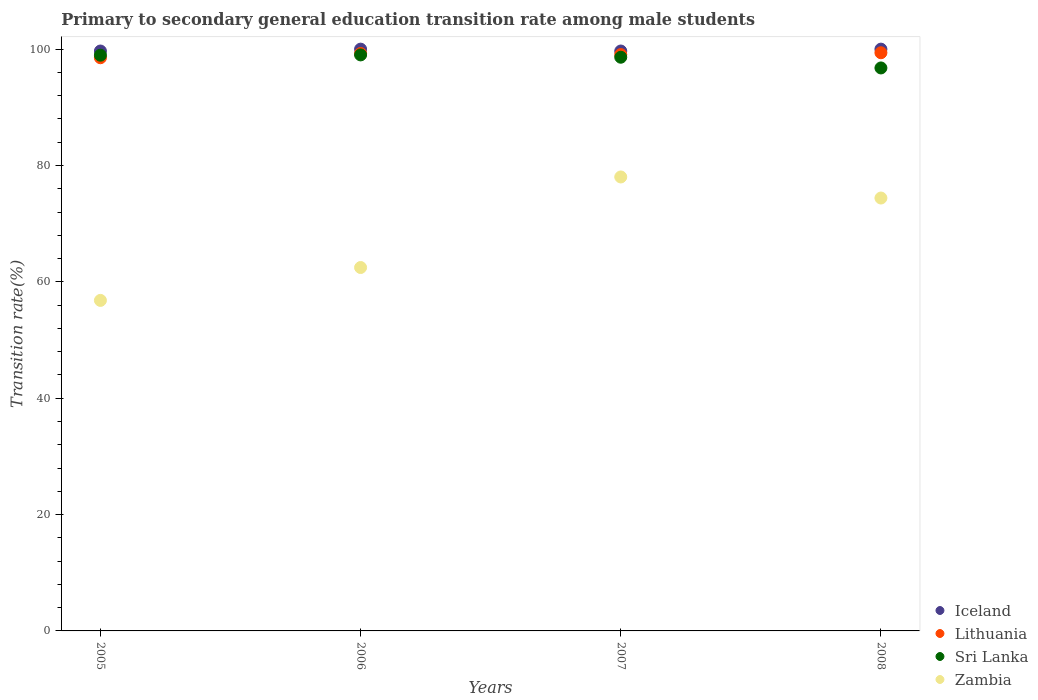Is the number of dotlines equal to the number of legend labels?
Your response must be concise. Yes. What is the transition rate in Lithuania in 2007?
Your answer should be compact. 99.07. Across all years, what is the maximum transition rate in Lithuania?
Give a very brief answer. 99.38. Across all years, what is the minimum transition rate in Sri Lanka?
Provide a short and direct response. 96.77. What is the total transition rate in Lithuania in the graph?
Make the answer very short. 396.22. What is the difference between the transition rate in Sri Lanka in 2006 and that in 2008?
Offer a very short reply. 2.24. What is the difference between the transition rate in Sri Lanka in 2006 and the transition rate in Lithuania in 2005?
Your answer should be compact. 0.49. What is the average transition rate in Sri Lanka per year?
Offer a very short reply. 98.34. In the year 2005, what is the difference between the transition rate in Sri Lanka and transition rate in Iceland?
Your response must be concise. -0.72. What is the ratio of the transition rate in Iceland in 2005 to that in 2008?
Offer a very short reply. 1. Is the transition rate in Lithuania in 2005 less than that in 2007?
Your response must be concise. Yes. What is the difference between the highest and the second highest transition rate in Zambia?
Ensure brevity in your answer.  3.62. What is the difference between the highest and the lowest transition rate in Lithuania?
Your answer should be compact. 0.86. In how many years, is the transition rate in Lithuania greater than the average transition rate in Lithuania taken over all years?
Your answer should be compact. 3. Is the transition rate in Sri Lanka strictly greater than the transition rate in Lithuania over the years?
Offer a very short reply. No. How are the legend labels stacked?
Provide a short and direct response. Vertical. What is the title of the graph?
Ensure brevity in your answer.  Primary to secondary general education transition rate among male students. What is the label or title of the Y-axis?
Your answer should be very brief. Transition rate(%). What is the Transition rate(%) in Iceland in 2005?
Give a very brief answer. 99.68. What is the Transition rate(%) of Lithuania in 2005?
Your answer should be compact. 98.52. What is the Transition rate(%) of Sri Lanka in 2005?
Keep it short and to the point. 98.96. What is the Transition rate(%) in Zambia in 2005?
Your answer should be compact. 56.81. What is the Transition rate(%) of Iceland in 2006?
Make the answer very short. 100. What is the Transition rate(%) of Lithuania in 2006?
Provide a short and direct response. 99.25. What is the Transition rate(%) in Sri Lanka in 2006?
Offer a very short reply. 99.01. What is the Transition rate(%) of Zambia in 2006?
Your answer should be compact. 62.46. What is the Transition rate(%) of Iceland in 2007?
Give a very brief answer. 99.68. What is the Transition rate(%) of Lithuania in 2007?
Your answer should be very brief. 99.07. What is the Transition rate(%) of Sri Lanka in 2007?
Your answer should be very brief. 98.61. What is the Transition rate(%) of Zambia in 2007?
Give a very brief answer. 78.03. What is the Transition rate(%) of Iceland in 2008?
Your answer should be very brief. 100. What is the Transition rate(%) in Lithuania in 2008?
Make the answer very short. 99.38. What is the Transition rate(%) of Sri Lanka in 2008?
Ensure brevity in your answer.  96.77. What is the Transition rate(%) of Zambia in 2008?
Provide a short and direct response. 74.41. Across all years, what is the maximum Transition rate(%) of Iceland?
Your answer should be very brief. 100. Across all years, what is the maximum Transition rate(%) of Lithuania?
Give a very brief answer. 99.38. Across all years, what is the maximum Transition rate(%) of Sri Lanka?
Your answer should be compact. 99.01. Across all years, what is the maximum Transition rate(%) of Zambia?
Your answer should be compact. 78.03. Across all years, what is the minimum Transition rate(%) of Iceland?
Keep it short and to the point. 99.68. Across all years, what is the minimum Transition rate(%) of Lithuania?
Your answer should be very brief. 98.52. Across all years, what is the minimum Transition rate(%) of Sri Lanka?
Your response must be concise. 96.77. Across all years, what is the minimum Transition rate(%) in Zambia?
Offer a terse response. 56.81. What is the total Transition rate(%) in Iceland in the graph?
Make the answer very short. 399.35. What is the total Transition rate(%) in Lithuania in the graph?
Provide a succinct answer. 396.22. What is the total Transition rate(%) of Sri Lanka in the graph?
Provide a succinct answer. 393.34. What is the total Transition rate(%) of Zambia in the graph?
Make the answer very short. 271.71. What is the difference between the Transition rate(%) in Iceland in 2005 and that in 2006?
Give a very brief answer. -0.32. What is the difference between the Transition rate(%) in Lithuania in 2005 and that in 2006?
Provide a succinct answer. -0.73. What is the difference between the Transition rate(%) in Sri Lanka in 2005 and that in 2006?
Offer a terse response. -0.05. What is the difference between the Transition rate(%) of Zambia in 2005 and that in 2006?
Your response must be concise. -5.65. What is the difference between the Transition rate(%) of Iceland in 2005 and that in 2007?
Your answer should be compact. -0. What is the difference between the Transition rate(%) of Lithuania in 2005 and that in 2007?
Make the answer very short. -0.55. What is the difference between the Transition rate(%) in Sri Lanka in 2005 and that in 2007?
Provide a short and direct response. 0.35. What is the difference between the Transition rate(%) of Zambia in 2005 and that in 2007?
Your response must be concise. -21.22. What is the difference between the Transition rate(%) in Iceland in 2005 and that in 2008?
Your response must be concise. -0.32. What is the difference between the Transition rate(%) in Lithuania in 2005 and that in 2008?
Offer a terse response. -0.86. What is the difference between the Transition rate(%) in Sri Lanka in 2005 and that in 2008?
Provide a short and direct response. 2.19. What is the difference between the Transition rate(%) of Zambia in 2005 and that in 2008?
Your answer should be compact. -17.6. What is the difference between the Transition rate(%) of Iceland in 2006 and that in 2007?
Your response must be concise. 0.32. What is the difference between the Transition rate(%) of Lithuania in 2006 and that in 2007?
Make the answer very short. 0.18. What is the difference between the Transition rate(%) in Sri Lanka in 2006 and that in 2007?
Ensure brevity in your answer.  0.4. What is the difference between the Transition rate(%) of Zambia in 2006 and that in 2007?
Provide a succinct answer. -15.57. What is the difference between the Transition rate(%) in Lithuania in 2006 and that in 2008?
Keep it short and to the point. -0.13. What is the difference between the Transition rate(%) of Sri Lanka in 2006 and that in 2008?
Keep it short and to the point. 2.24. What is the difference between the Transition rate(%) in Zambia in 2006 and that in 2008?
Your answer should be very brief. -11.94. What is the difference between the Transition rate(%) in Iceland in 2007 and that in 2008?
Offer a terse response. -0.32. What is the difference between the Transition rate(%) in Lithuania in 2007 and that in 2008?
Offer a very short reply. -0.31. What is the difference between the Transition rate(%) in Sri Lanka in 2007 and that in 2008?
Ensure brevity in your answer.  1.84. What is the difference between the Transition rate(%) of Zambia in 2007 and that in 2008?
Ensure brevity in your answer.  3.62. What is the difference between the Transition rate(%) in Iceland in 2005 and the Transition rate(%) in Lithuania in 2006?
Give a very brief answer. 0.42. What is the difference between the Transition rate(%) of Iceland in 2005 and the Transition rate(%) of Sri Lanka in 2006?
Offer a terse response. 0.67. What is the difference between the Transition rate(%) of Iceland in 2005 and the Transition rate(%) of Zambia in 2006?
Offer a very short reply. 37.21. What is the difference between the Transition rate(%) of Lithuania in 2005 and the Transition rate(%) of Sri Lanka in 2006?
Provide a succinct answer. -0.49. What is the difference between the Transition rate(%) of Lithuania in 2005 and the Transition rate(%) of Zambia in 2006?
Offer a terse response. 36.06. What is the difference between the Transition rate(%) in Sri Lanka in 2005 and the Transition rate(%) in Zambia in 2006?
Offer a very short reply. 36.49. What is the difference between the Transition rate(%) of Iceland in 2005 and the Transition rate(%) of Lithuania in 2007?
Your response must be concise. 0.61. What is the difference between the Transition rate(%) in Iceland in 2005 and the Transition rate(%) in Sri Lanka in 2007?
Offer a very short reply. 1.07. What is the difference between the Transition rate(%) of Iceland in 2005 and the Transition rate(%) of Zambia in 2007?
Provide a succinct answer. 21.65. What is the difference between the Transition rate(%) of Lithuania in 2005 and the Transition rate(%) of Sri Lanka in 2007?
Offer a terse response. -0.09. What is the difference between the Transition rate(%) of Lithuania in 2005 and the Transition rate(%) of Zambia in 2007?
Provide a short and direct response. 20.49. What is the difference between the Transition rate(%) of Sri Lanka in 2005 and the Transition rate(%) of Zambia in 2007?
Your answer should be compact. 20.93. What is the difference between the Transition rate(%) in Iceland in 2005 and the Transition rate(%) in Lithuania in 2008?
Your answer should be very brief. 0.3. What is the difference between the Transition rate(%) of Iceland in 2005 and the Transition rate(%) of Sri Lanka in 2008?
Provide a short and direct response. 2.91. What is the difference between the Transition rate(%) of Iceland in 2005 and the Transition rate(%) of Zambia in 2008?
Offer a terse response. 25.27. What is the difference between the Transition rate(%) of Lithuania in 2005 and the Transition rate(%) of Sri Lanka in 2008?
Give a very brief answer. 1.75. What is the difference between the Transition rate(%) of Lithuania in 2005 and the Transition rate(%) of Zambia in 2008?
Make the answer very short. 24.11. What is the difference between the Transition rate(%) of Sri Lanka in 2005 and the Transition rate(%) of Zambia in 2008?
Offer a very short reply. 24.55. What is the difference between the Transition rate(%) of Iceland in 2006 and the Transition rate(%) of Lithuania in 2007?
Ensure brevity in your answer.  0.93. What is the difference between the Transition rate(%) in Iceland in 2006 and the Transition rate(%) in Sri Lanka in 2007?
Ensure brevity in your answer.  1.39. What is the difference between the Transition rate(%) of Iceland in 2006 and the Transition rate(%) of Zambia in 2007?
Keep it short and to the point. 21.97. What is the difference between the Transition rate(%) in Lithuania in 2006 and the Transition rate(%) in Sri Lanka in 2007?
Offer a very short reply. 0.64. What is the difference between the Transition rate(%) of Lithuania in 2006 and the Transition rate(%) of Zambia in 2007?
Ensure brevity in your answer.  21.22. What is the difference between the Transition rate(%) in Sri Lanka in 2006 and the Transition rate(%) in Zambia in 2007?
Offer a terse response. 20.98. What is the difference between the Transition rate(%) of Iceland in 2006 and the Transition rate(%) of Lithuania in 2008?
Provide a short and direct response. 0.62. What is the difference between the Transition rate(%) in Iceland in 2006 and the Transition rate(%) in Sri Lanka in 2008?
Ensure brevity in your answer.  3.23. What is the difference between the Transition rate(%) in Iceland in 2006 and the Transition rate(%) in Zambia in 2008?
Ensure brevity in your answer.  25.59. What is the difference between the Transition rate(%) in Lithuania in 2006 and the Transition rate(%) in Sri Lanka in 2008?
Offer a terse response. 2.48. What is the difference between the Transition rate(%) in Lithuania in 2006 and the Transition rate(%) in Zambia in 2008?
Offer a terse response. 24.84. What is the difference between the Transition rate(%) of Sri Lanka in 2006 and the Transition rate(%) of Zambia in 2008?
Offer a terse response. 24.6. What is the difference between the Transition rate(%) in Iceland in 2007 and the Transition rate(%) in Lithuania in 2008?
Your response must be concise. 0.3. What is the difference between the Transition rate(%) of Iceland in 2007 and the Transition rate(%) of Sri Lanka in 2008?
Give a very brief answer. 2.91. What is the difference between the Transition rate(%) of Iceland in 2007 and the Transition rate(%) of Zambia in 2008?
Ensure brevity in your answer.  25.27. What is the difference between the Transition rate(%) in Lithuania in 2007 and the Transition rate(%) in Sri Lanka in 2008?
Provide a succinct answer. 2.3. What is the difference between the Transition rate(%) of Lithuania in 2007 and the Transition rate(%) of Zambia in 2008?
Your answer should be very brief. 24.66. What is the difference between the Transition rate(%) of Sri Lanka in 2007 and the Transition rate(%) of Zambia in 2008?
Provide a short and direct response. 24.2. What is the average Transition rate(%) of Iceland per year?
Your response must be concise. 99.84. What is the average Transition rate(%) in Lithuania per year?
Ensure brevity in your answer.  99.05. What is the average Transition rate(%) in Sri Lanka per year?
Offer a very short reply. 98.34. What is the average Transition rate(%) in Zambia per year?
Make the answer very short. 67.93. In the year 2005, what is the difference between the Transition rate(%) in Iceland and Transition rate(%) in Lithuania?
Ensure brevity in your answer.  1.16. In the year 2005, what is the difference between the Transition rate(%) in Iceland and Transition rate(%) in Sri Lanka?
Give a very brief answer. 0.72. In the year 2005, what is the difference between the Transition rate(%) of Iceland and Transition rate(%) of Zambia?
Give a very brief answer. 42.86. In the year 2005, what is the difference between the Transition rate(%) of Lithuania and Transition rate(%) of Sri Lanka?
Your answer should be very brief. -0.44. In the year 2005, what is the difference between the Transition rate(%) in Lithuania and Transition rate(%) in Zambia?
Offer a very short reply. 41.71. In the year 2005, what is the difference between the Transition rate(%) of Sri Lanka and Transition rate(%) of Zambia?
Provide a succinct answer. 42.15. In the year 2006, what is the difference between the Transition rate(%) of Iceland and Transition rate(%) of Lithuania?
Offer a terse response. 0.75. In the year 2006, what is the difference between the Transition rate(%) of Iceland and Transition rate(%) of Sri Lanka?
Offer a terse response. 0.99. In the year 2006, what is the difference between the Transition rate(%) of Iceland and Transition rate(%) of Zambia?
Make the answer very short. 37.54. In the year 2006, what is the difference between the Transition rate(%) of Lithuania and Transition rate(%) of Sri Lanka?
Offer a terse response. 0.24. In the year 2006, what is the difference between the Transition rate(%) in Lithuania and Transition rate(%) in Zambia?
Your answer should be very brief. 36.79. In the year 2006, what is the difference between the Transition rate(%) of Sri Lanka and Transition rate(%) of Zambia?
Provide a succinct answer. 36.54. In the year 2007, what is the difference between the Transition rate(%) in Iceland and Transition rate(%) in Lithuania?
Make the answer very short. 0.61. In the year 2007, what is the difference between the Transition rate(%) of Iceland and Transition rate(%) of Sri Lanka?
Provide a short and direct response. 1.07. In the year 2007, what is the difference between the Transition rate(%) in Iceland and Transition rate(%) in Zambia?
Your answer should be compact. 21.65. In the year 2007, what is the difference between the Transition rate(%) in Lithuania and Transition rate(%) in Sri Lanka?
Provide a succinct answer. 0.46. In the year 2007, what is the difference between the Transition rate(%) in Lithuania and Transition rate(%) in Zambia?
Make the answer very short. 21.04. In the year 2007, what is the difference between the Transition rate(%) in Sri Lanka and Transition rate(%) in Zambia?
Give a very brief answer. 20.58. In the year 2008, what is the difference between the Transition rate(%) in Iceland and Transition rate(%) in Lithuania?
Provide a succinct answer. 0.62. In the year 2008, what is the difference between the Transition rate(%) of Iceland and Transition rate(%) of Sri Lanka?
Ensure brevity in your answer.  3.23. In the year 2008, what is the difference between the Transition rate(%) of Iceland and Transition rate(%) of Zambia?
Provide a succinct answer. 25.59. In the year 2008, what is the difference between the Transition rate(%) of Lithuania and Transition rate(%) of Sri Lanka?
Give a very brief answer. 2.61. In the year 2008, what is the difference between the Transition rate(%) in Lithuania and Transition rate(%) in Zambia?
Your answer should be compact. 24.97. In the year 2008, what is the difference between the Transition rate(%) of Sri Lanka and Transition rate(%) of Zambia?
Offer a terse response. 22.36. What is the ratio of the Transition rate(%) of Zambia in 2005 to that in 2006?
Provide a succinct answer. 0.91. What is the ratio of the Transition rate(%) of Iceland in 2005 to that in 2007?
Keep it short and to the point. 1. What is the ratio of the Transition rate(%) in Lithuania in 2005 to that in 2007?
Ensure brevity in your answer.  0.99. What is the ratio of the Transition rate(%) in Sri Lanka in 2005 to that in 2007?
Your answer should be compact. 1. What is the ratio of the Transition rate(%) of Zambia in 2005 to that in 2007?
Provide a short and direct response. 0.73. What is the ratio of the Transition rate(%) of Iceland in 2005 to that in 2008?
Offer a terse response. 1. What is the ratio of the Transition rate(%) in Sri Lanka in 2005 to that in 2008?
Your answer should be compact. 1.02. What is the ratio of the Transition rate(%) in Zambia in 2005 to that in 2008?
Your response must be concise. 0.76. What is the ratio of the Transition rate(%) of Iceland in 2006 to that in 2007?
Your response must be concise. 1. What is the ratio of the Transition rate(%) of Lithuania in 2006 to that in 2007?
Make the answer very short. 1. What is the ratio of the Transition rate(%) of Sri Lanka in 2006 to that in 2007?
Offer a terse response. 1. What is the ratio of the Transition rate(%) in Zambia in 2006 to that in 2007?
Keep it short and to the point. 0.8. What is the ratio of the Transition rate(%) of Lithuania in 2006 to that in 2008?
Offer a very short reply. 1. What is the ratio of the Transition rate(%) of Sri Lanka in 2006 to that in 2008?
Your answer should be very brief. 1.02. What is the ratio of the Transition rate(%) of Zambia in 2006 to that in 2008?
Offer a terse response. 0.84. What is the ratio of the Transition rate(%) in Iceland in 2007 to that in 2008?
Give a very brief answer. 1. What is the ratio of the Transition rate(%) in Zambia in 2007 to that in 2008?
Your response must be concise. 1.05. What is the difference between the highest and the second highest Transition rate(%) in Lithuania?
Your response must be concise. 0.13. What is the difference between the highest and the second highest Transition rate(%) of Sri Lanka?
Ensure brevity in your answer.  0.05. What is the difference between the highest and the second highest Transition rate(%) in Zambia?
Offer a terse response. 3.62. What is the difference between the highest and the lowest Transition rate(%) in Iceland?
Your response must be concise. 0.32. What is the difference between the highest and the lowest Transition rate(%) of Lithuania?
Provide a succinct answer. 0.86. What is the difference between the highest and the lowest Transition rate(%) of Sri Lanka?
Offer a very short reply. 2.24. What is the difference between the highest and the lowest Transition rate(%) of Zambia?
Your answer should be very brief. 21.22. 